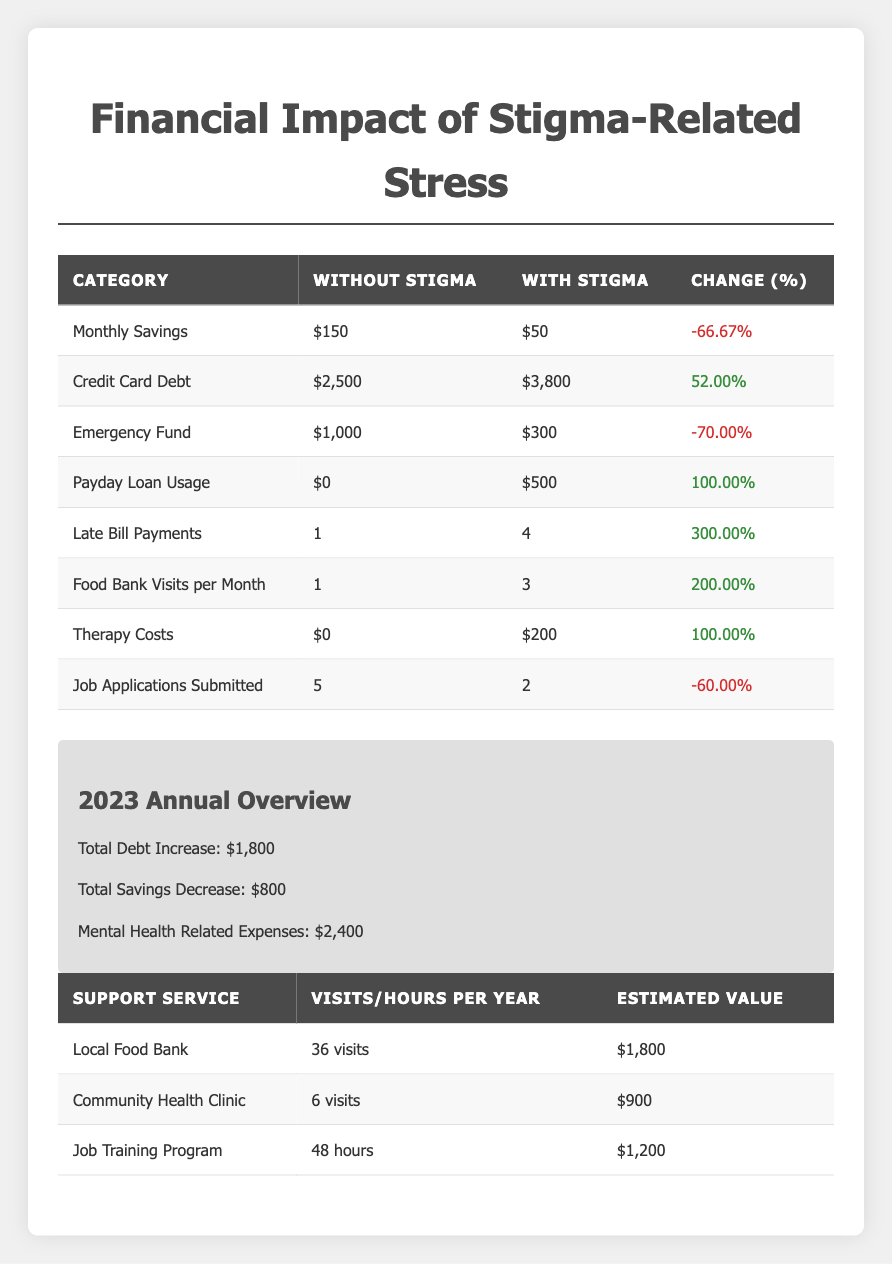What is the percentage change in monthly savings with stigma compared to without stigma? The monthly savings without stigma is $150, and with stigma, it is $50. To find the percentage change, we use the formula: ((with stigma - without stigma) / without stigma) * 100 = (($50 - $150) / $150) * 100 = -66.67%.
Answer: -66.67% How much did credit card debt increase when stigma is present? The credit card debt without stigma is $2,500 and with stigma, it is $3,800. The increase is calculated as follows: $3,800 - $2,500 = $1,300.
Answer: $1,300 Is the emergency fund higher or lower with stigma compared to without stigma? The emergency fund is $1,000 without stigma and $300 with stigma. Since $300 is less than $1,000, it is lower with stigma.
Answer: Lower What is the total increase in debt for the year 2023? According to the annual overview, the total debt increase for the year 2023 is given directly as $1,800.
Answer: $1,800 Considering both the emergency fund and monthly savings, what is the total decrease in these two categories due to stigma? The decrease in the emergency fund is $1,000 - $300 = $700, and the decrease in monthly savings is $150 - $50 = $100. Therefore, the total decrease is $700 + $100 = $800.
Answer: $800 Did the number of job applications submitted increase or decrease with stigma? The number of job applications submitted without stigma is 5, while with stigma, it is only 2, indicating a decrease.
Answer: Decrease How many food bank visits are reported per month with stigma? The table states that the food bank visits per month with stigma are 3.
Answer: 3 What is the estimated value of the community health clinic visits per year? The estimated value of visits to the community health clinic per year is directly listed as $900 in the support services table.
Answer: $900 If all mental health-related expenses for 2023 are summed, what is the total? The total mental health-related expenses are given as $2,400 for the year 2023. This value represents the overall expenses in that category.
Answer: $2,400 